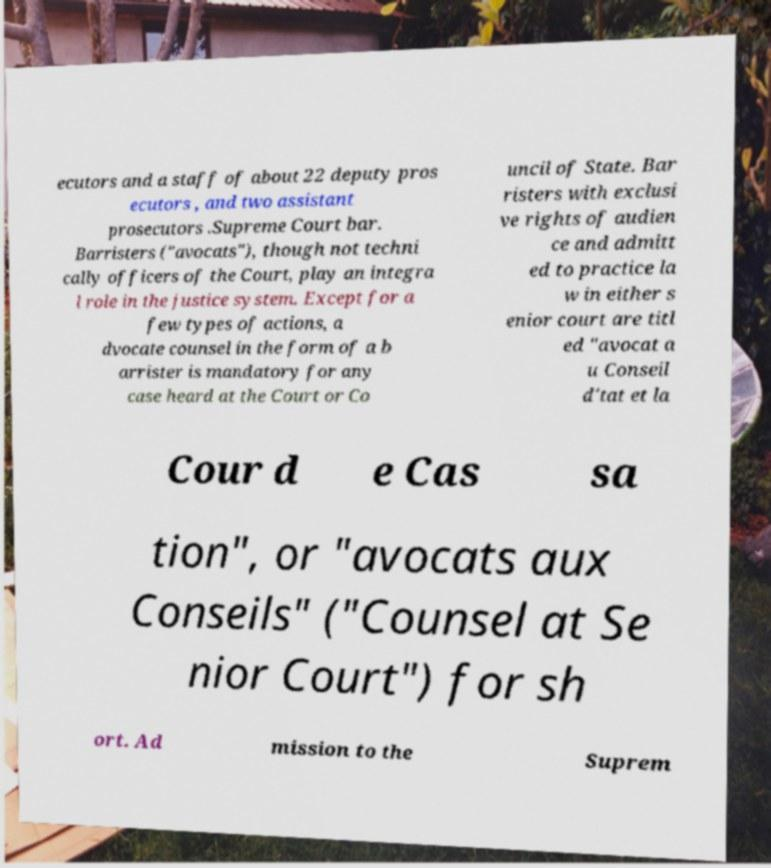There's text embedded in this image that I need extracted. Can you transcribe it verbatim? ecutors and a staff of about 22 deputy pros ecutors , and two assistant prosecutors .Supreme Court bar. Barristers ("avocats"), though not techni cally officers of the Court, play an integra l role in the justice system. Except for a few types of actions, a dvocate counsel in the form of a b arrister is mandatory for any case heard at the Court or Co uncil of State. Bar risters with exclusi ve rights of audien ce and admitt ed to practice la w in either s enior court are titl ed "avocat a u Conseil d'tat et la Cour d e Cas sa tion", or "avocats aux Conseils" ("Counsel at Se nior Court") for sh ort. Ad mission to the Suprem 